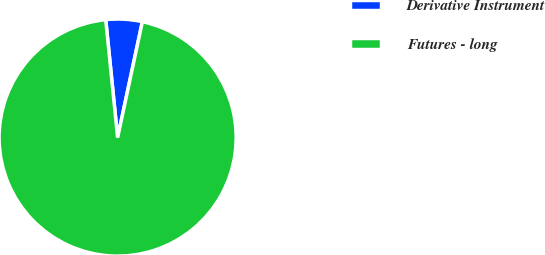Convert chart to OTSL. <chart><loc_0><loc_0><loc_500><loc_500><pie_chart><fcel>Derivative Instrument<fcel>Futures - long<nl><fcel>4.95%<fcel>95.05%<nl></chart> 